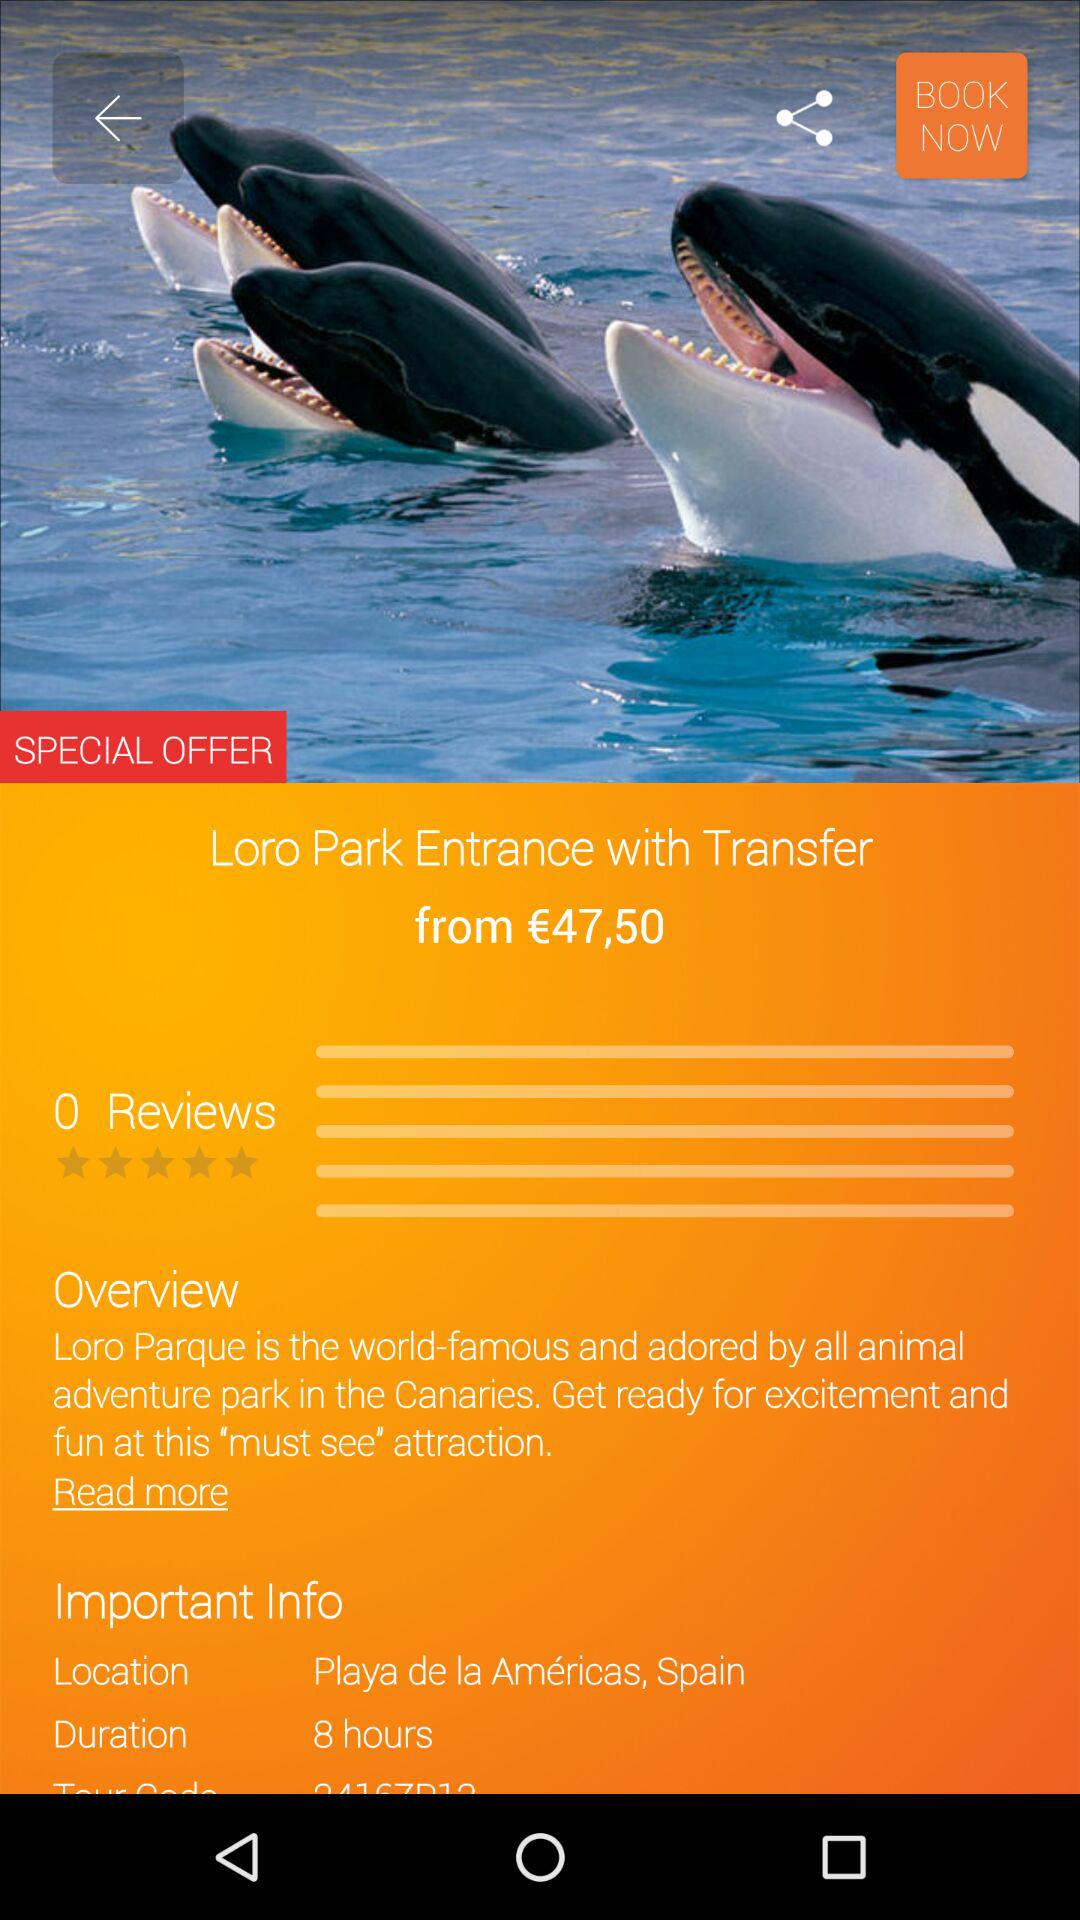What is the duration shown on the screen? The duration shown on the screen is 8 hours. 